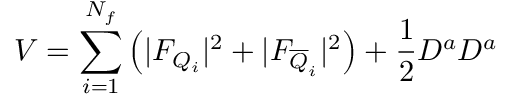Convert formula to latex. <formula><loc_0><loc_0><loc_500><loc_500>V = \sum _ { i = 1 } ^ { N _ { f } } \left ( | F _ { Q _ { i } } | ^ { 2 } + | F _ { \overline { Q } _ { i } } | ^ { 2 } \right ) + \frac { 1 } { 2 } D ^ { a } D ^ { a }</formula> 